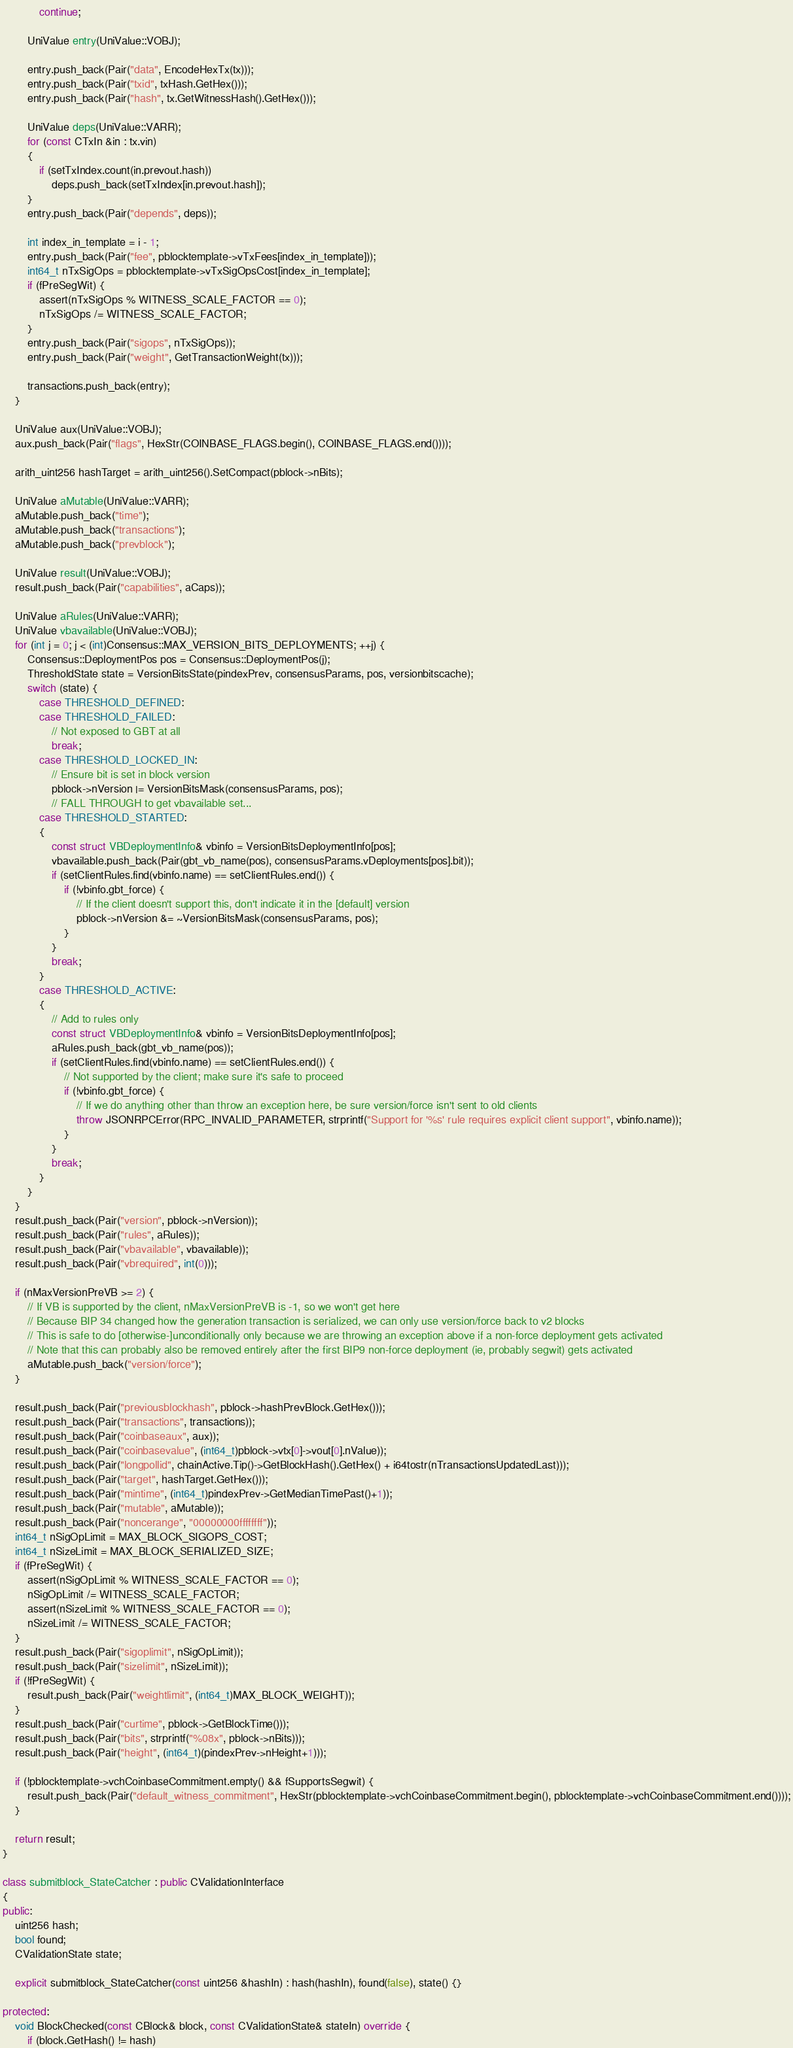<code> <loc_0><loc_0><loc_500><loc_500><_C++_>            continue;

        UniValue entry(UniValue::VOBJ);

        entry.push_back(Pair("data", EncodeHexTx(tx)));
        entry.push_back(Pair("txid", txHash.GetHex()));
        entry.push_back(Pair("hash", tx.GetWitnessHash().GetHex()));

        UniValue deps(UniValue::VARR);
        for (const CTxIn &in : tx.vin)
        {
            if (setTxIndex.count(in.prevout.hash))
                deps.push_back(setTxIndex[in.prevout.hash]);
        }
        entry.push_back(Pair("depends", deps));

        int index_in_template = i - 1;
        entry.push_back(Pair("fee", pblocktemplate->vTxFees[index_in_template]));
        int64_t nTxSigOps = pblocktemplate->vTxSigOpsCost[index_in_template];
        if (fPreSegWit) {
            assert(nTxSigOps % WITNESS_SCALE_FACTOR == 0);
            nTxSigOps /= WITNESS_SCALE_FACTOR;
        }
        entry.push_back(Pair("sigops", nTxSigOps));
        entry.push_back(Pair("weight", GetTransactionWeight(tx)));

        transactions.push_back(entry);
    }

    UniValue aux(UniValue::VOBJ);
    aux.push_back(Pair("flags", HexStr(COINBASE_FLAGS.begin(), COINBASE_FLAGS.end())));

    arith_uint256 hashTarget = arith_uint256().SetCompact(pblock->nBits);

    UniValue aMutable(UniValue::VARR);
    aMutable.push_back("time");
    aMutable.push_back("transactions");
    aMutable.push_back("prevblock");

    UniValue result(UniValue::VOBJ);
    result.push_back(Pair("capabilities", aCaps));

    UniValue aRules(UniValue::VARR);
    UniValue vbavailable(UniValue::VOBJ);
    for (int j = 0; j < (int)Consensus::MAX_VERSION_BITS_DEPLOYMENTS; ++j) {
        Consensus::DeploymentPos pos = Consensus::DeploymentPos(j);
        ThresholdState state = VersionBitsState(pindexPrev, consensusParams, pos, versionbitscache);
        switch (state) {
            case THRESHOLD_DEFINED:
            case THRESHOLD_FAILED:
                // Not exposed to GBT at all
                break;
            case THRESHOLD_LOCKED_IN:
                // Ensure bit is set in block version
                pblock->nVersion |= VersionBitsMask(consensusParams, pos);
                // FALL THROUGH to get vbavailable set...
            case THRESHOLD_STARTED:
            {
                const struct VBDeploymentInfo& vbinfo = VersionBitsDeploymentInfo[pos];
                vbavailable.push_back(Pair(gbt_vb_name(pos), consensusParams.vDeployments[pos].bit));
                if (setClientRules.find(vbinfo.name) == setClientRules.end()) {
                    if (!vbinfo.gbt_force) {
                        // If the client doesn't support this, don't indicate it in the [default] version
                        pblock->nVersion &= ~VersionBitsMask(consensusParams, pos);
                    }
                }
                break;
            }
            case THRESHOLD_ACTIVE:
            {
                // Add to rules only
                const struct VBDeploymentInfo& vbinfo = VersionBitsDeploymentInfo[pos];
                aRules.push_back(gbt_vb_name(pos));
                if (setClientRules.find(vbinfo.name) == setClientRules.end()) {
                    // Not supported by the client; make sure it's safe to proceed
                    if (!vbinfo.gbt_force) {
                        // If we do anything other than throw an exception here, be sure version/force isn't sent to old clients
                        throw JSONRPCError(RPC_INVALID_PARAMETER, strprintf("Support for '%s' rule requires explicit client support", vbinfo.name));
                    }
                }
                break;
            }
        }
    }
    result.push_back(Pair("version", pblock->nVersion));
    result.push_back(Pair("rules", aRules));
    result.push_back(Pair("vbavailable", vbavailable));
    result.push_back(Pair("vbrequired", int(0)));

    if (nMaxVersionPreVB >= 2) {
        // If VB is supported by the client, nMaxVersionPreVB is -1, so we won't get here
        // Because BIP 34 changed how the generation transaction is serialized, we can only use version/force back to v2 blocks
        // This is safe to do [otherwise-]unconditionally only because we are throwing an exception above if a non-force deployment gets activated
        // Note that this can probably also be removed entirely after the first BIP9 non-force deployment (ie, probably segwit) gets activated
        aMutable.push_back("version/force");
    }

    result.push_back(Pair("previousblockhash", pblock->hashPrevBlock.GetHex()));
    result.push_back(Pair("transactions", transactions));
    result.push_back(Pair("coinbaseaux", aux));
    result.push_back(Pair("coinbasevalue", (int64_t)pblock->vtx[0]->vout[0].nValue));
    result.push_back(Pair("longpollid", chainActive.Tip()->GetBlockHash().GetHex() + i64tostr(nTransactionsUpdatedLast)));
    result.push_back(Pair("target", hashTarget.GetHex()));
    result.push_back(Pair("mintime", (int64_t)pindexPrev->GetMedianTimePast()+1));
    result.push_back(Pair("mutable", aMutable));
    result.push_back(Pair("noncerange", "00000000ffffffff"));
    int64_t nSigOpLimit = MAX_BLOCK_SIGOPS_COST;
    int64_t nSizeLimit = MAX_BLOCK_SERIALIZED_SIZE;
    if (fPreSegWit) {
        assert(nSigOpLimit % WITNESS_SCALE_FACTOR == 0);
        nSigOpLimit /= WITNESS_SCALE_FACTOR;
        assert(nSizeLimit % WITNESS_SCALE_FACTOR == 0);
        nSizeLimit /= WITNESS_SCALE_FACTOR;
    }
    result.push_back(Pair("sigoplimit", nSigOpLimit));
    result.push_back(Pair("sizelimit", nSizeLimit));
    if (!fPreSegWit) {
        result.push_back(Pair("weightlimit", (int64_t)MAX_BLOCK_WEIGHT));
    }
    result.push_back(Pair("curtime", pblock->GetBlockTime()));
    result.push_back(Pair("bits", strprintf("%08x", pblock->nBits)));
    result.push_back(Pair("height", (int64_t)(pindexPrev->nHeight+1)));

    if (!pblocktemplate->vchCoinbaseCommitment.empty() && fSupportsSegwit) {
        result.push_back(Pair("default_witness_commitment", HexStr(pblocktemplate->vchCoinbaseCommitment.begin(), pblocktemplate->vchCoinbaseCommitment.end())));
    }

    return result;
}

class submitblock_StateCatcher : public CValidationInterface
{
public:
    uint256 hash;
    bool found;
    CValidationState state;

    explicit submitblock_StateCatcher(const uint256 &hashIn) : hash(hashIn), found(false), state() {}

protected:
    void BlockChecked(const CBlock& block, const CValidationState& stateIn) override {
        if (block.GetHash() != hash)</code> 